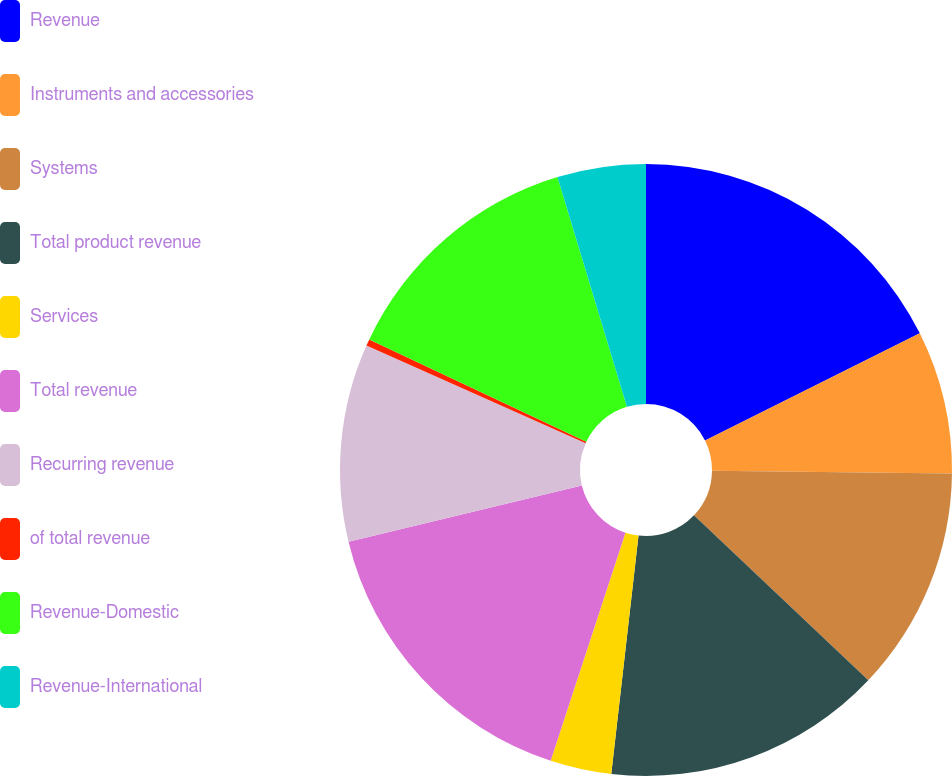Convert chart. <chart><loc_0><loc_0><loc_500><loc_500><pie_chart><fcel>Revenue<fcel>Instruments and accessories<fcel>Systems<fcel>Total product revenue<fcel>Services<fcel>Total revenue<fcel>Recurring revenue<fcel>of total revenue<fcel>Revenue-Domestic<fcel>Revenue-International<nl><fcel>17.63%<fcel>7.55%<fcel>11.87%<fcel>14.75%<fcel>3.23%<fcel>16.19%<fcel>10.43%<fcel>0.35%<fcel>13.31%<fcel>4.67%<nl></chart> 